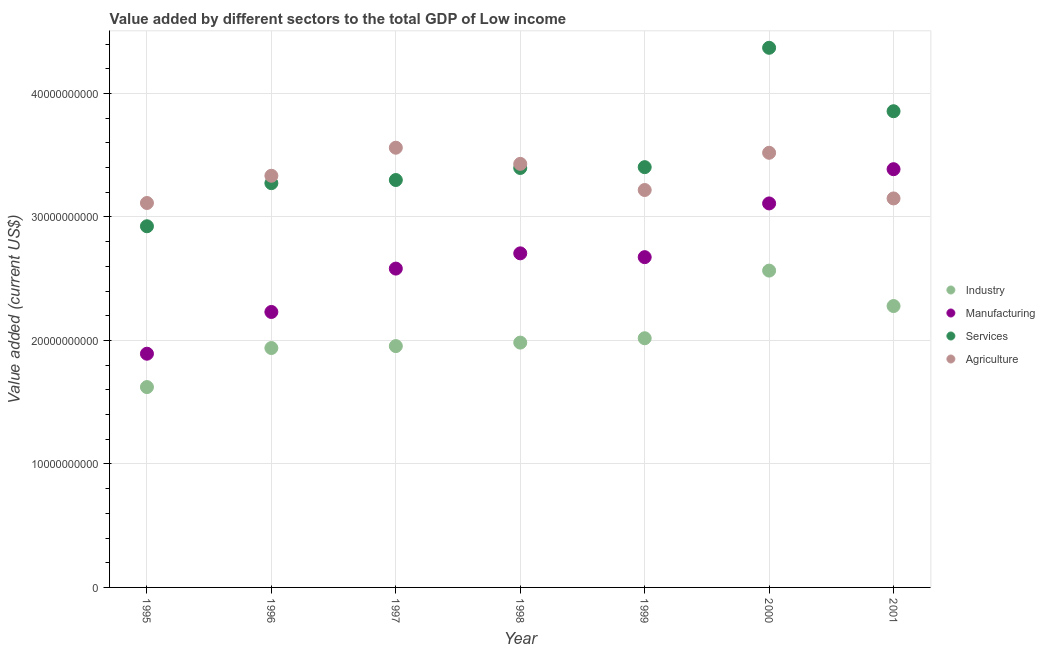What is the value added by manufacturing sector in 1998?
Provide a short and direct response. 2.70e+1. Across all years, what is the maximum value added by agricultural sector?
Offer a very short reply. 3.56e+1. Across all years, what is the minimum value added by manufacturing sector?
Your response must be concise. 1.89e+1. What is the total value added by industrial sector in the graph?
Offer a very short reply. 1.44e+11. What is the difference between the value added by services sector in 1996 and that in 1999?
Give a very brief answer. -1.30e+09. What is the difference between the value added by services sector in 2000 and the value added by industrial sector in 1996?
Ensure brevity in your answer.  2.43e+1. What is the average value added by industrial sector per year?
Your response must be concise. 2.05e+1. In the year 1996, what is the difference between the value added by agricultural sector and value added by manufacturing sector?
Keep it short and to the point. 1.10e+1. What is the ratio of the value added by industrial sector in 1995 to that in 1999?
Keep it short and to the point. 0.8. Is the value added by manufacturing sector in 1997 less than that in 1998?
Keep it short and to the point. Yes. What is the difference between the highest and the second highest value added by agricultural sector?
Keep it short and to the point. 4.10e+08. What is the difference between the highest and the lowest value added by services sector?
Your response must be concise. 1.45e+1. In how many years, is the value added by services sector greater than the average value added by services sector taken over all years?
Provide a short and direct response. 2. Is the sum of the value added by industrial sector in 1996 and 1999 greater than the maximum value added by agricultural sector across all years?
Your answer should be very brief. Yes. Is the value added by services sector strictly greater than the value added by industrial sector over the years?
Keep it short and to the point. Yes. Is the value added by manufacturing sector strictly less than the value added by agricultural sector over the years?
Give a very brief answer. No. How many years are there in the graph?
Your answer should be very brief. 7. What is the difference between two consecutive major ticks on the Y-axis?
Your answer should be compact. 1.00e+1. Are the values on the major ticks of Y-axis written in scientific E-notation?
Your answer should be very brief. No. Does the graph contain grids?
Your answer should be very brief. Yes. Where does the legend appear in the graph?
Your response must be concise. Center right. How are the legend labels stacked?
Make the answer very short. Vertical. What is the title of the graph?
Ensure brevity in your answer.  Value added by different sectors to the total GDP of Low income. Does "Overall level" appear as one of the legend labels in the graph?
Make the answer very short. No. What is the label or title of the X-axis?
Ensure brevity in your answer.  Year. What is the label or title of the Y-axis?
Offer a terse response. Value added (current US$). What is the Value added (current US$) in Industry in 1995?
Offer a very short reply. 1.62e+1. What is the Value added (current US$) of Manufacturing in 1995?
Give a very brief answer. 1.89e+1. What is the Value added (current US$) in Services in 1995?
Offer a terse response. 2.92e+1. What is the Value added (current US$) of Agriculture in 1995?
Provide a succinct answer. 3.11e+1. What is the Value added (current US$) of Industry in 1996?
Provide a short and direct response. 1.94e+1. What is the Value added (current US$) of Manufacturing in 1996?
Your response must be concise. 2.23e+1. What is the Value added (current US$) of Services in 1996?
Offer a very short reply. 3.27e+1. What is the Value added (current US$) in Agriculture in 1996?
Your answer should be very brief. 3.33e+1. What is the Value added (current US$) of Industry in 1997?
Make the answer very short. 1.95e+1. What is the Value added (current US$) of Manufacturing in 1997?
Provide a short and direct response. 2.58e+1. What is the Value added (current US$) of Services in 1997?
Provide a succinct answer. 3.30e+1. What is the Value added (current US$) in Agriculture in 1997?
Keep it short and to the point. 3.56e+1. What is the Value added (current US$) in Industry in 1998?
Your answer should be compact. 1.98e+1. What is the Value added (current US$) of Manufacturing in 1998?
Offer a very short reply. 2.70e+1. What is the Value added (current US$) of Services in 1998?
Offer a terse response. 3.40e+1. What is the Value added (current US$) of Agriculture in 1998?
Provide a succinct answer. 3.43e+1. What is the Value added (current US$) in Industry in 1999?
Provide a short and direct response. 2.02e+1. What is the Value added (current US$) of Manufacturing in 1999?
Keep it short and to the point. 2.67e+1. What is the Value added (current US$) in Services in 1999?
Your answer should be compact. 3.40e+1. What is the Value added (current US$) of Agriculture in 1999?
Your response must be concise. 3.22e+1. What is the Value added (current US$) in Industry in 2000?
Give a very brief answer. 2.57e+1. What is the Value added (current US$) of Manufacturing in 2000?
Make the answer very short. 3.11e+1. What is the Value added (current US$) in Services in 2000?
Provide a succinct answer. 4.37e+1. What is the Value added (current US$) of Agriculture in 2000?
Make the answer very short. 3.52e+1. What is the Value added (current US$) in Industry in 2001?
Your answer should be very brief. 2.28e+1. What is the Value added (current US$) in Manufacturing in 2001?
Offer a very short reply. 3.39e+1. What is the Value added (current US$) of Services in 2001?
Provide a short and direct response. 3.86e+1. What is the Value added (current US$) in Agriculture in 2001?
Offer a terse response. 3.15e+1. Across all years, what is the maximum Value added (current US$) of Industry?
Offer a terse response. 2.57e+1. Across all years, what is the maximum Value added (current US$) in Manufacturing?
Offer a very short reply. 3.39e+1. Across all years, what is the maximum Value added (current US$) in Services?
Your response must be concise. 4.37e+1. Across all years, what is the maximum Value added (current US$) in Agriculture?
Provide a succinct answer. 3.56e+1. Across all years, what is the minimum Value added (current US$) in Industry?
Offer a terse response. 1.62e+1. Across all years, what is the minimum Value added (current US$) in Manufacturing?
Offer a terse response. 1.89e+1. Across all years, what is the minimum Value added (current US$) of Services?
Offer a very short reply. 2.92e+1. Across all years, what is the minimum Value added (current US$) of Agriculture?
Provide a succinct answer. 3.11e+1. What is the total Value added (current US$) of Industry in the graph?
Ensure brevity in your answer.  1.44e+11. What is the total Value added (current US$) in Manufacturing in the graph?
Provide a short and direct response. 1.86e+11. What is the total Value added (current US$) of Services in the graph?
Ensure brevity in your answer.  2.45e+11. What is the total Value added (current US$) of Agriculture in the graph?
Your response must be concise. 2.33e+11. What is the difference between the Value added (current US$) in Industry in 1995 and that in 1996?
Offer a very short reply. -3.16e+09. What is the difference between the Value added (current US$) of Manufacturing in 1995 and that in 1996?
Offer a very short reply. -3.38e+09. What is the difference between the Value added (current US$) of Services in 1995 and that in 1996?
Offer a very short reply. -3.49e+09. What is the difference between the Value added (current US$) in Agriculture in 1995 and that in 1996?
Your answer should be very brief. -2.20e+09. What is the difference between the Value added (current US$) in Industry in 1995 and that in 1997?
Keep it short and to the point. -3.32e+09. What is the difference between the Value added (current US$) of Manufacturing in 1995 and that in 1997?
Offer a terse response. -6.89e+09. What is the difference between the Value added (current US$) in Services in 1995 and that in 1997?
Offer a very short reply. -3.74e+09. What is the difference between the Value added (current US$) of Agriculture in 1995 and that in 1997?
Offer a very short reply. -4.48e+09. What is the difference between the Value added (current US$) of Industry in 1995 and that in 1998?
Offer a very short reply. -3.60e+09. What is the difference between the Value added (current US$) in Manufacturing in 1995 and that in 1998?
Provide a short and direct response. -8.13e+09. What is the difference between the Value added (current US$) of Services in 1995 and that in 1998?
Your response must be concise. -4.72e+09. What is the difference between the Value added (current US$) in Agriculture in 1995 and that in 1998?
Ensure brevity in your answer.  -3.17e+09. What is the difference between the Value added (current US$) of Industry in 1995 and that in 1999?
Keep it short and to the point. -3.95e+09. What is the difference between the Value added (current US$) in Manufacturing in 1995 and that in 1999?
Provide a succinct answer. -7.82e+09. What is the difference between the Value added (current US$) in Services in 1995 and that in 1999?
Your response must be concise. -4.79e+09. What is the difference between the Value added (current US$) of Agriculture in 1995 and that in 1999?
Give a very brief answer. -1.05e+09. What is the difference between the Value added (current US$) of Industry in 1995 and that in 2000?
Offer a terse response. -9.43e+09. What is the difference between the Value added (current US$) in Manufacturing in 1995 and that in 2000?
Provide a succinct answer. -1.22e+1. What is the difference between the Value added (current US$) of Services in 1995 and that in 2000?
Your answer should be compact. -1.45e+1. What is the difference between the Value added (current US$) in Agriculture in 1995 and that in 2000?
Provide a short and direct response. -4.07e+09. What is the difference between the Value added (current US$) in Industry in 1995 and that in 2001?
Provide a short and direct response. -6.56e+09. What is the difference between the Value added (current US$) in Manufacturing in 1995 and that in 2001?
Your answer should be very brief. -1.49e+1. What is the difference between the Value added (current US$) of Services in 1995 and that in 2001?
Your answer should be compact. -9.31e+09. What is the difference between the Value added (current US$) of Agriculture in 1995 and that in 2001?
Give a very brief answer. -3.69e+08. What is the difference between the Value added (current US$) of Industry in 1996 and that in 1997?
Keep it short and to the point. -1.56e+08. What is the difference between the Value added (current US$) of Manufacturing in 1996 and that in 1997?
Give a very brief answer. -3.51e+09. What is the difference between the Value added (current US$) in Services in 1996 and that in 1997?
Give a very brief answer. -2.54e+08. What is the difference between the Value added (current US$) of Agriculture in 1996 and that in 1997?
Your response must be concise. -2.27e+09. What is the difference between the Value added (current US$) of Industry in 1996 and that in 1998?
Ensure brevity in your answer.  -4.39e+08. What is the difference between the Value added (current US$) in Manufacturing in 1996 and that in 1998?
Offer a very short reply. -4.75e+09. What is the difference between the Value added (current US$) of Services in 1996 and that in 1998?
Your response must be concise. -1.23e+09. What is the difference between the Value added (current US$) in Agriculture in 1996 and that in 1998?
Provide a short and direct response. -9.64e+08. What is the difference between the Value added (current US$) of Industry in 1996 and that in 1999?
Keep it short and to the point. -7.92e+08. What is the difference between the Value added (current US$) in Manufacturing in 1996 and that in 1999?
Make the answer very short. -4.44e+09. What is the difference between the Value added (current US$) of Services in 1996 and that in 1999?
Provide a short and direct response. -1.30e+09. What is the difference between the Value added (current US$) in Agriculture in 1996 and that in 1999?
Your answer should be compact. 1.15e+09. What is the difference between the Value added (current US$) in Industry in 1996 and that in 2000?
Your answer should be compact. -6.27e+09. What is the difference between the Value added (current US$) in Manufacturing in 1996 and that in 2000?
Your answer should be very brief. -8.79e+09. What is the difference between the Value added (current US$) in Services in 1996 and that in 2000?
Your response must be concise. -1.10e+1. What is the difference between the Value added (current US$) of Agriculture in 1996 and that in 2000?
Your answer should be very brief. -1.86e+09. What is the difference between the Value added (current US$) in Industry in 1996 and that in 2001?
Offer a very short reply. -3.40e+09. What is the difference between the Value added (current US$) in Manufacturing in 1996 and that in 2001?
Your response must be concise. -1.16e+1. What is the difference between the Value added (current US$) in Services in 1996 and that in 2001?
Your answer should be compact. -5.82e+09. What is the difference between the Value added (current US$) in Agriculture in 1996 and that in 2001?
Give a very brief answer. 1.84e+09. What is the difference between the Value added (current US$) of Industry in 1997 and that in 1998?
Provide a short and direct response. -2.83e+08. What is the difference between the Value added (current US$) of Manufacturing in 1997 and that in 1998?
Provide a short and direct response. -1.23e+09. What is the difference between the Value added (current US$) of Services in 1997 and that in 1998?
Keep it short and to the point. -9.76e+08. What is the difference between the Value added (current US$) of Agriculture in 1997 and that in 1998?
Provide a succinct answer. 1.31e+09. What is the difference between the Value added (current US$) in Industry in 1997 and that in 1999?
Your response must be concise. -6.36e+08. What is the difference between the Value added (current US$) of Manufacturing in 1997 and that in 1999?
Ensure brevity in your answer.  -9.26e+08. What is the difference between the Value added (current US$) of Services in 1997 and that in 1999?
Ensure brevity in your answer.  -1.04e+09. What is the difference between the Value added (current US$) in Agriculture in 1997 and that in 1999?
Provide a short and direct response. 3.42e+09. What is the difference between the Value added (current US$) in Industry in 1997 and that in 2000?
Offer a terse response. -6.11e+09. What is the difference between the Value added (current US$) of Manufacturing in 1997 and that in 2000?
Provide a short and direct response. -5.28e+09. What is the difference between the Value added (current US$) in Services in 1997 and that in 2000?
Provide a short and direct response. -1.07e+1. What is the difference between the Value added (current US$) in Agriculture in 1997 and that in 2000?
Keep it short and to the point. 4.10e+08. What is the difference between the Value added (current US$) in Industry in 1997 and that in 2001?
Make the answer very short. -3.24e+09. What is the difference between the Value added (current US$) in Manufacturing in 1997 and that in 2001?
Offer a very short reply. -8.05e+09. What is the difference between the Value added (current US$) in Services in 1997 and that in 2001?
Give a very brief answer. -5.57e+09. What is the difference between the Value added (current US$) of Agriculture in 1997 and that in 2001?
Keep it short and to the point. 4.11e+09. What is the difference between the Value added (current US$) of Industry in 1998 and that in 1999?
Offer a terse response. -3.53e+08. What is the difference between the Value added (current US$) in Manufacturing in 1998 and that in 1999?
Your response must be concise. 3.08e+08. What is the difference between the Value added (current US$) of Services in 1998 and that in 1999?
Make the answer very short. -6.67e+07. What is the difference between the Value added (current US$) in Agriculture in 1998 and that in 1999?
Your response must be concise. 2.12e+09. What is the difference between the Value added (current US$) of Industry in 1998 and that in 2000?
Your answer should be compact. -5.83e+09. What is the difference between the Value added (current US$) of Manufacturing in 1998 and that in 2000?
Provide a short and direct response. -4.04e+09. What is the difference between the Value added (current US$) of Services in 1998 and that in 2000?
Offer a very short reply. -9.73e+09. What is the difference between the Value added (current US$) in Agriculture in 1998 and that in 2000?
Your answer should be compact. -8.97e+08. What is the difference between the Value added (current US$) of Industry in 1998 and that in 2001?
Provide a short and direct response. -2.96e+09. What is the difference between the Value added (current US$) in Manufacturing in 1998 and that in 2001?
Provide a short and direct response. -6.81e+09. What is the difference between the Value added (current US$) in Services in 1998 and that in 2001?
Your answer should be compact. -4.59e+09. What is the difference between the Value added (current US$) of Agriculture in 1998 and that in 2001?
Provide a succinct answer. 2.80e+09. What is the difference between the Value added (current US$) of Industry in 1999 and that in 2000?
Offer a very short reply. -5.48e+09. What is the difference between the Value added (current US$) of Manufacturing in 1999 and that in 2000?
Give a very brief answer. -4.35e+09. What is the difference between the Value added (current US$) in Services in 1999 and that in 2000?
Offer a terse response. -9.66e+09. What is the difference between the Value added (current US$) in Agriculture in 1999 and that in 2000?
Keep it short and to the point. -3.01e+09. What is the difference between the Value added (current US$) of Industry in 1999 and that in 2001?
Offer a very short reply. -2.61e+09. What is the difference between the Value added (current US$) in Manufacturing in 1999 and that in 2001?
Make the answer very short. -7.12e+09. What is the difference between the Value added (current US$) in Services in 1999 and that in 2001?
Ensure brevity in your answer.  -4.53e+09. What is the difference between the Value added (current US$) of Agriculture in 1999 and that in 2001?
Provide a short and direct response. 6.83e+08. What is the difference between the Value added (current US$) in Industry in 2000 and that in 2001?
Your answer should be compact. 2.87e+09. What is the difference between the Value added (current US$) of Manufacturing in 2000 and that in 2001?
Give a very brief answer. -2.77e+09. What is the difference between the Value added (current US$) of Services in 2000 and that in 2001?
Give a very brief answer. 5.14e+09. What is the difference between the Value added (current US$) of Agriculture in 2000 and that in 2001?
Ensure brevity in your answer.  3.70e+09. What is the difference between the Value added (current US$) of Industry in 1995 and the Value added (current US$) of Manufacturing in 1996?
Offer a terse response. -6.08e+09. What is the difference between the Value added (current US$) in Industry in 1995 and the Value added (current US$) in Services in 1996?
Keep it short and to the point. -1.65e+1. What is the difference between the Value added (current US$) of Industry in 1995 and the Value added (current US$) of Agriculture in 1996?
Make the answer very short. -1.71e+1. What is the difference between the Value added (current US$) in Manufacturing in 1995 and the Value added (current US$) in Services in 1996?
Keep it short and to the point. -1.38e+1. What is the difference between the Value added (current US$) in Manufacturing in 1995 and the Value added (current US$) in Agriculture in 1996?
Ensure brevity in your answer.  -1.44e+1. What is the difference between the Value added (current US$) in Services in 1995 and the Value added (current US$) in Agriculture in 1996?
Your response must be concise. -4.09e+09. What is the difference between the Value added (current US$) of Industry in 1995 and the Value added (current US$) of Manufacturing in 1997?
Your answer should be compact. -9.59e+09. What is the difference between the Value added (current US$) in Industry in 1995 and the Value added (current US$) in Services in 1997?
Ensure brevity in your answer.  -1.68e+1. What is the difference between the Value added (current US$) in Industry in 1995 and the Value added (current US$) in Agriculture in 1997?
Your answer should be compact. -1.94e+1. What is the difference between the Value added (current US$) in Manufacturing in 1995 and the Value added (current US$) in Services in 1997?
Keep it short and to the point. -1.41e+1. What is the difference between the Value added (current US$) of Manufacturing in 1995 and the Value added (current US$) of Agriculture in 1997?
Make the answer very short. -1.67e+1. What is the difference between the Value added (current US$) of Services in 1995 and the Value added (current US$) of Agriculture in 1997?
Your answer should be very brief. -6.36e+09. What is the difference between the Value added (current US$) of Industry in 1995 and the Value added (current US$) of Manufacturing in 1998?
Your response must be concise. -1.08e+1. What is the difference between the Value added (current US$) in Industry in 1995 and the Value added (current US$) in Services in 1998?
Provide a short and direct response. -1.77e+1. What is the difference between the Value added (current US$) in Industry in 1995 and the Value added (current US$) in Agriculture in 1998?
Your answer should be compact. -1.81e+1. What is the difference between the Value added (current US$) in Manufacturing in 1995 and the Value added (current US$) in Services in 1998?
Offer a very short reply. -1.50e+1. What is the difference between the Value added (current US$) in Manufacturing in 1995 and the Value added (current US$) in Agriculture in 1998?
Keep it short and to the point. -1.54e+1. What is the difference between the Value added (current US$) of Services in 1995 and the Value added (current US$) of Agriculture in 1998?
Offer a terse response. -5.05e+09. What is the difference between the Value added (current US$) in Industry in 1995 and the Value added (current US$) in Manufacturing in 1999?
Offer a terse response. -1.05e+1. What is the difference between the Value added (current US$) of Industry in 1995 and the Value added (current US$) of Services in 1999?
Your answer should be very brief. -1.78e+1. What is the difference between the Value added (current US$) of Industry in 1995 and the Value added (current US$) of Agriculture in 1999?
Your answer should be compact. -1.60e+1. What is the difference between the Value added (current US$) of Manufacturing in 1995 and the Value added (current US$) of Services in 1999?
Your answer should be compact. -1.51e+1. What is the difference between the Value added (current US$) of Manufacturing in 1995 and the Value added (current US$) of Agriculture in 1999?
Offer a very short reply. -1.33e+1. What is the difference between the Value added (current US$) of Services in 1995 and the Value added (current US$) of Agriculture in 1999?
Provide a succinct answer. -2.94e+09. What is the difference between the Value added (current US$) of Industry in 1995 and the Value added (current US$) of Manufacturing in 2000?
Provide a succinct answer. -1.49e+1. What is the difference between the Value added (current US$) in Industry in 1995 and the Value added (current US$) in Services in 2000?
Give a very brief answer. -2.75e+1. What is the difference between the Value added (current US$) of Industry in 1995 and the Value added (current US$) of Agriculture in 2000?
Provide a short and direct response. -1.90e+1. What is the difference between the Value added (current US$) of Manufacturing in 1995 and the Value added (current US$) of Services in 2000?
Make the answer very short. -2.48e+1. What is the difference between the Value added (current US$) in Manufacturing in 1995 and the Value added (current US$) in Agriculture in 2000?
Keep it short and to the point. -1.63e+1. What is the difference between the Value added (current US$) in Services in 1995 and the Value added (current US$) in Agriculture in 2000?
Ensure brevity in your answer.  -5.95e+09. What is the difference between the Value added (current US$) in Industry in 1995 and the Value added (current US$) in Manufacturing in 2001?
Provide a succinct answer. -1.76e+1. What is the difference between the Value added (current US$) of Industry in 1995 and the Value added (current US$) of Services in 2001?
Make the answer very short. -2.23e+1. What is the difference between the Value added (current US$) in Industry in 1995 and the Value added (current US$) in Agriculture in 2001?
Your response must be concise. -1.53e+1. What is the difference between the Value added (current US$) in Manufacturing in 1995 and the Value added (current US$) in Services in 2001?
Offer a terse response. -1.96e+1. What is the difference between the Value added (current US$) in Manufacturing in 1995 and the Value added (current US$) in Agriculture in 2001?
Your response must be concise. -1.26e+1. What is the difference between the Value added (current US$) in Services in 1995 and the Value added (current US$) in Agriculture in 2001?
Make the answer very short. -2.25e+09. What is the difference between the Value added (current US$) of Industry in 1996 and the Value added (current US$) of Manufacturing in 1997?
Offer a very short reply. -6.43e+09. What is the difference between the Value added (current US$) of Industry in 1996 and the Value added (current US$) of Services in 1997?
Your response must be concise. -1.36e+1. What is the difference between the Value added (current US$) in Industry in 1996 and the Value added (current US$) in Agriculture in 1997?
Your answer should be compact. -1.62e+1. What is the difference between the Value added (current US$) in Manufacturing in 1996 and the Value added (current US$) in Services in 1997?
Ensure brevity in your answer.  -1.07e+1. What is the difference between the Value added (current US$) in Manufacturing in 1996 and the Value added (current US$) in Agriculture in 1997?
Keep it short and to the point. -1.33e+1. What is the difference between the Value added (current US$) in Services in 1996 and the Value added (current US$) in Agriculture in 1997?
Your response must be concise. -2.87e+09. What is the difference between the Value added (current US$) in Industry in 1996 and the Value added (current US$) in Manufacturing in 1998?
Make the answer very short. -7.67e+09. What is the difference between the Value added (current US$) in Industry in 1996 and the Value added (current US$) in Services in 1998?
Provide a short and direct response. -1.46e+1. What is the difference between the Value added (current US$) in Industry in 1996 and the Value added (current US$) in Agriculture in 1998?
Make the answer very short. -1.49e+1. What is the difference between the Value added (current US$) of Manufacturing in 1996 and the Value added (current US$) of Services in 1998?
Offer a terse response. -1.17e+1. What is the difference between the Value added (current US$) of Manufacturing in 1996 and the Value added (current US$) of Agriculture in 1998?
Your response must be concise. -1.20e+1. What is the difference between the Value added (current US$) of Services in 1996 and the Value added (current US$) of Agriculture in 1998?
Provide a short and direct response. -1.56e+09. What is the difference between the Value added (current US$) of Industry in 1996 and the Value added (current US$) of Manufacturing in 1999?
Make the answer very short. -7.36e+09. What is the difference between the Value added (current US$) in Industry in 1996 and the Value added (current US$) in Services in 1999?
Your answer should be compact. -1.46e+1. What is the difference between the Value added (current US$) of Industry in 1996 and the Value added (current US$) of Agriculture in 1999?
Keep it short and to the point. -1.28e+1. What is the difference between the Value added (current US$) in Manufacturing in 1996 and the Value added (current US$) in Services in 1999?
Offer a terse response. -1.17e+1. What is the difference between the Value added (current US$) in Manufacturing in 1996 and the Value added (current US$) in Agriculture in 1999?
Give a very brief answer. -9.88e+09. What is the difference between the Value added (current US$) in Services in 1996 and the Value added (current US$) in Agriculture in 1999?
Ensure brevity in your answer.  5.54e+08. What is the difference between the Value added (current US$) in Industry in 1996 and the Value added (current US$) in Manufacturing in 2000?
Your response must be concise. -1.17e+1. What is the difference between the Value added (current US$) in Industry in 1996 and the Value added (current US$) in Services in 2000?
Provide a short and direct response. -2.43e+1. What is the difference between the Value added (current US$) of Industry in 1996 and the Value added (current US$) of Agriculture in 2000?
Offer a terse response. -1.58e+1. What is the difference between the Value added (current US$) in Manufacturing in 1996 and the Value added (current US$) in Services in 2000?
Keep it short and to the point. -2.14e+1. What is the difference between the Value added (current US$) of Manufacturing in 1996 and the Value added (current US$) of Agriculture in 2000?
Offer a very short reply. -1.29e+1. What is the difference between the Value added (current US$) of Services in 1996 and the Value added (current US$) of Agriculture in 2000?
Your answer should be compact. -2.46e+09. What is the difference between the Value added (current US$) of Industry in 1996 and the Value added (current US$) of Manufacturing in 2001?
Your response must be concise. -1.45e+1. What is the difference between the Value added (current US$) of Industry in 1996 and the Value added (current US$) of Services in 2001?
Make the answer very short. -1.92e+1. What is the difference between the Value added (current US$) in Industry in 1996 and the Value added (current US$) in Agriculture in 2001?
Ensure brevity in your answer.  -1.21e+1. What is the difference between the Value added (current US$) in Manufacturing in 1996 and the Value added (current US$) in Services in 2001?
Make the answer very short. -1.63e+1. What is the difference between the Value added (current US$) of Manufacturing in 1996 and the Value added (current US$) of Agriculture in 2001?
Give a very brief answer. -9.19e+09. What is the difference between the Value added (current US$) of Services in 1996 and the Value added (current US$) of Agriculture in 2001?
Ensure brevity in your answer.  1.24e+09. What is the difference between the Value added (current US$) in Industry in 1997 and the Value added (current US$) in Manufacturing in 1998?
Your answer should be very brief. -7.51e+09. What is the difference between the Value added (current US$) of Industry in 1997 and the Value added (current US$) of Services in 1998?
Provide a succinct answer. -1.44e+1. What is the difference between the Value added (current US$) in Industry in 1997 and the Value added (current US$) in Agriculture in 1998?
Provide a succinct answer. -1.48e+1. What is the difference between the Value added (current US$) of Manufacturing in 1997 and the Value added (current US$) of Services in 1998?
Provide a succinct answer. -8.15e+09. What is the difference between the Value added (current US$) of Manufacturing in 1997 and the Value added (current US$) of Agriculture in 1998?
Keep it short and to the point. -8.48e+09. What is the difference between the Value added (current US$) in Services in 1997 and the Value added (current US$) in Agriculture in 1998?
Your answer should be very brief. -1.31e+09. What is the difference between the Value added (current US$) in Industry in 1997 and the Value added (current US$) in Manufacturing in 1999?
Offer a terse response. -7.20e+09. What is the difference between the Value added (current US$) in Industry in 1997 and the Value added (current US$) in Services in 1999?
Give a very brief answer. -1.45e+1. What is the difference between the Value added (current US$) in Industry in 1997 and the Value added (current US$) in Agriculture in 1999?
Keep it short and to the point. -1.26e+1. What is the difference between the Value added (current US$) in Manufacturing in 1997 and the Value added (current US$) in Services in 1999?
Your response must be concise. -8.21e+09. What is the difference between the Value added (current US$) of Manufacturing in 1997 and the Value added (current US$) of Agriculture in 1999?
Provide a short and direct response. -6.36e+09. What is the difference between the Value added (current US$) in Services in 1997 and the Value added (current US$) in Agriculture in 1999?
Provide a succinct answer. 8.08e+08. What is the difference between the Value added (current US$) of Industry in 1997 and the Value added (current US$) of Manufacturing in 2000?
Provide a short and direct response. -1.16e+1. What is the difference between the Value added (current US$) of Industry in 1997 and the Value added (current US$) of Services in 2000?
Your answer should be compact. -2.42e+1. What is the difference between the Value added (current US$) of Industry in 1997 and the Value added (current US$) of Agriculture in 2000?
Your response must be concise. -1.57e+1. What is the difference between the Value added (current US$) in Manufacturing in 1997 and the Value added (current US$) in Services in 2000?
Your answer should be compact. -1.79e+1. What is the difference between the Value added (current US$) of Manufacturing in 1997 and the Value added (current US$) of Agriculture in 2000?
Your response must be concise. -9.38e+09. What is the difference between the Value added (current US$) of Services in 1997 and the Value added (current US$) of Agriculture in 2000?
Offer a very short reply. -2.21e+09. What is the difference between the Value added (current US$) in Industry in 1997 and the Value added (current US$) in Manufacturing in 2001?
Provide a succinct answer. -1.43e+1. What is the difference between the Value added (current US$) in Industry in 1997 and the Value added (current US$) in Services in 2001?
Ensure brevity in your answer.  -1.90e+1. What is the difference between the Value added (current US$) in Industry in 1997 and the Value added (current US$) in Agriculture in 2001?
Offer a very short reply. -1.20e+1. What is the difference between the Value added (current US$) of Manufacturing in 1997 and the Value added (current US$) of Services in 2001?
Make the answer very short. -1.27e+1. What is the difference between the Value added (current US$) of Manufacturing in 1997 and the Value added (current US$) of Agriculture in 2001?
Offer a terse response. -5.68e+09. What is the difference between the Value added (current US$) of Services in 1997 and the Value added (current US$) of Agriculture in 2001?
Your response must be concise. 1.49e+09. What is the difference between the Value added (current US$) of Industry in 1998 and the Value added (current US$) of Manufacturing in 1999?
Keep it short and to the point. -6.92e+09. What is the difference between the Value added (current US$) of Industry in 1998 and the Value added (current US$) of Services in 1999?
Your response must be concise. -1.42e+1. What is the difference between the Value added (current US$) in Industry in 1998 and the Value added (current US$) in Agriculture in 1999?
Offer a very short reply. -1.24e+1. What is the difference between the Value added (current US$) of Manufacturing in 1998 and the Value added (current US$) of Services in 1999?
Your answer should be very brief. -6.98e+09. What is the difference between the Value added (current US$) in Manufacturing in 1998 and the Value added (current US$) in Agriculture in 1999?
Your response must be concise. -5.13e+09. What is the difference between the Value added (current US$) in Services in 1998 and the Value added (current US$) in Agriculture in 1999?
Your response must be concise. 1.78e+09. What is the difference between the Value added (current US$) of Industry in 1998 and the Value added (current US$) of Manufacturing in 2000?
Give a very brief answer. -1.13e+1. What is the difference between the Value added (current US$) of Industry in 1998 and the Value added (current US$) of Services in 2000?
Make the answer very short. -2.39e+1. What is the difference between the Value added (current US$) in Industry in 1998 and the Value added (current US$) in Agriculture in 2000?
Keep it short and to the point. -1.54e+1. What is the difference between the Value added (current US$) of Manufacturing in 1998 and the Value added (current US$) of Services in 2000?
Provide a succinct answer. -1.66e+1. What is the difference between the Value added (current US$) in Manufacturing in 1998 and the Value added (current US$) in Agriculture in 2000?
Your response must be concise. -8.14e+09. What is the difference between the Value added (current US$) of Services in 1998 and the Value added (current US$) of Agriculture in 2000?
Your answer should be very brief. -1.23e+09. What is the difference between the Value added (current US$) of Industry in 1998 and the Value added (current US$) of Manufacturing in 2001?
Make the answer very short. -1.40e+1. What is the difference between the Value added (current US$) in Industry in 1998 and the Value added (current US$) in Services in 2001?
Keep it short and to the point. -1.87e+1. What is the difference between the Value added (current US$) of Industry in 1998 and the Value added (current US$) of Agriculture in 2001?
Provide a short and direct response. -1.17e+1. What is the difference between the Value added (current US$) in Manufacturing in 1998 and the Value added (current US$) in Services in 2001?
Your answer should be very brief. -1.15e+1. What is the difference between the Value added (current US$) of Manufacturing in 1998 and the Value added (current US$) of Agriculture in 2001?
Offer a very short reply. -4.45e+09. What is the difference between the Value added (current US$) in Services in 1998 and the Value added (current US$) in Agriculture in 2001?
Your response must be concise. 2.47e+09. What is the difference between the Value added (current US$) of Industry in 1999 and the Value added (current US$) of Manufacturing in 2000?
Make the answer very short. -1.09e+1. What is the difference between the Value added (current US$) of Industry in 1999 and the Value added (current US$) of Services in 2000?
Your answer should be very brief. -2.35e+1. What is the difference between the Value added (current US$) of Industry in 1999 and the Value added (current US$) of Agriculture in 2000?
Provide a short and direct response. -1.50e+1. What is the difference between the Value added (current US$) of Manufacturing in 1999 and the Value added (current US$) of Services in 2000?
Your answer should be compact. -1.70e+1. What is the difference between the Value added (current US$) of Manufacturing in 1999 and the Value added (current US$) of Agriculture in 2000?
Your answer should be compact. -8.45e+09. What is the difference between the Value added (current US$) of Services in 1999 and the Value added (current US$) of Agriculture in 2000?
Your response must be concise. -1.16e+09. What is the difference between the Value added (current US$) in Industry in 1999 and the Value added (current US$) in Manufacturing in 2001?
Your answer should be compact. -1.37e+1. What is the difference between the Value added (current US$) in Industry in 1999 and the Value added (current US$) in Services in 2001?
Ensure brevity in your answer.  -1.84e+1. What is the difference between the Value added (current US$) in Industry in 1999 and the Value added (current US$) in Agriculture in 2001?
Your answer should be very brief. -1.13e+1. What is the difference between the Value added (current US$) in Manufacturing in 1999 and the Value added (current US$) in Services in 2001?
Offer a terse response. -1.18e+1. What is the difference between the Value added (current US$) of Manufacturing in 1999 and the Value added (current US$) of Agriculture in 2001?
Your answer should be very brief. -4.75e+09. What is the difference between the Value added (current US$) in Services in 1999 and the Value added (current US$) in Agriculture in 2001?
Provide a succinct answer. 2.53e+09. What is the difference between the Value added (current US$) in Industry in 2000 and the Value added (current US$) in Manufacturing in 2001?
Your response must be concise. -8.21e+09. What is the difference between the Value added (current US$) in Industry in 2000 and the Value added (current US$) in Services in 2001?
Provide a succinct answer. -1.29e+1. What is the difference between the Value added (current US$) in Industry in 2000 and the Value added (current US$) in Agriculture in 2001?
Ensure brevity in your answer.  -5.84e+09. What is the difference between the Value added (current US$) in Manufacturing in 2000 and the Value added (current US$) in Services in 2001?
Offer a terse response. -7.47e+09. What is the difference between the Value added (current US$) of Manufacturing in 2000 and the Value added (current US$) of Agriculture in 2001?
Give a very brief answer. -4.04e+08. What is the difference between the Value added (current US$) in Services in 2000 and the Value added (current US$) in Agriculture in 2001?
Your response must be concise. 1.22e+1. What is the average Value added (current US$) of Industry per year?
Offer a very short reply. 2.05e+1. What is the average Value added (current US$) of Manufacturing per year?
Offer a terse response. 2.65e+1. What is the average Value added (current US$) of Services per year?
Your answer should be very brief. 3.50e+1. What is the average Value added (current US$) of Agriculture per year?
Ensure brevity in your answer.  3.33e+1. In the year 1995, what is the difference between the Value added (current US$) of Industry and Value added (current US$) of Manufacturing?
Offer a terse response. -2.70e+09. In the year 1995, what is the difference between the Value added (current US$) of Industry and Value added (current US$) of Services?
Keep it short and to the point. -1.30e+1. In the year 1995, what is the difference between the Value added (current US$) of Industry and Value added (current US$) of Agriculture?
Provide a short and direct response. -1.49e+1. In the year 1995, what is the difference between the Value added (current US$) in Manufacturing and Value added (current US$) in Services?
Provide a succinct answer. -1.03e+1. In the year 1995, what is the difference between the Value added (current US$) of Manufacturing and Value added (current US$) of Agriculture?
Offer a terse response. -1.22e+1. In the year 1995, what is the difference between the Value added (current US$) of Services and Value added (current US$) of Agriculture?
Offer a terse response. -1.88e+09. In the year 1996, what is the difference between the Value added (current US$) of Industry and Value added (current US$) of Manufacturing?
Ensure brevity in your answer.  -2.92e+09. In the year 1996, what is the difference between the Value added (current US$) of Industry and Value added (current US$) of Services?
Give a very brief answer. -1.33e+1. In the year 1996, what is the difference between the Value added (current US$) of Industry and Value added (current US$) of Agriculture?
Keep it short and to the point. -1.39e+1. In the year 1996, what is the difference between the Value added (current US$) of Manufacturing and Value added (current US$) of Services?
Make the answer very short. -1.04e+1. In the year 1996, what is the difference between the Value added (current US$) in Manufacturing and Value added (current US$) in Agriculture?
Your answer should be very brief. -1.10e+1. In the year 1996, what is the difference between the Value added (current US$) of Services and Value added (current US$) of Agriculture?
Your answer should be very brief. -5.98e+08. In the year 1997, what is the difference between the Value added (current US$) of Industry and Value added (current US$) of Manufacturing?
Provide a succinct answer. -6.28e+09. In the year 1997, what is the difference between the Value added (current US$) of Industry and Value added (current US$) of Services?
Your answer should be very brief. -1.34e+1. In the year 1997, what is the difference between the Value added (current US$) in Industry and Value added (current US$) in Agriculture?
Your answer should be very brief. -1.61e+1. In the year 1997, what is the difference between the Value added (current US$) of Manufacturing and Value added (current US$) of Services?
Your response must be concise. -7.17e+09. In the year 1997, what is the difference between the Value added (current US$) of Manufacturing and Value added (current US$) of Agriculture?
Give a very brief answer. -9.79e+09. In the year 1997, what is the difference between the Value added (current US$) of Services and Value added (current US$) of Agriculture?
Give a very brief answer. -2.62e+09. In the year 1998, what is the difference between the Value added (current US$) in Industry and Value added (current US$) in Manufacturing?
Offer a very short reply. -7.23e+09. In the year 1998, what is the difference between the Value added (current US$) of Industry and Value added (current US$) of Services?
Provide a succinct answer. -1.41e+1. In the year 1998, what is the difference between the Value added (current US$) of Industry and Value added (current US$) of Agriculture?
Keep it short and to the point. -1.45e+1. In the year 1998, what is the difference between the Value added (current US$) in Manufacturing and Value added (current US$) in Services?
Offer a terse response. -6.91e+09. In the year 1998, what is the difference between the Value added (current US$) of Manufacturing and Value added (current US$) of Agriculture?
Provide a succinct answer. -7.25e+09. In the year 1998, what is the difference between the Value added (current US$) of Services and Value added (current US$) of Agriculture?
Your response must be concise. -3.32e+08. In the year 1999, what is the difference between the Value added (current US$) in Industry and Value added (current US$) in Manufacturing?
Keep it short and to the point. -6.57e+09. In the year 1999, what is the difference between the Value added (current US$) of Industry and Value added (current US$) of Services?
Ensure brevity in your answer.  -1.39e+1. In the year 1999, what is the difference between the Value added (current US$) in Industry and Value added (current US$) in Agriculture?
Offer a terse response. -1.20e+1. In the year 1999, what is the difference between the Value added (current US$) in Manufacturing and Value added (current US$) in Services?
Your answer should be compact. -7.29e+09. In the year 1999, what is the difference between the Value added (current US$) in Manufacturing and Value added (current US$) in Agriculture?
Provide a short and direct response. -5.44e+09. In the year 1999, what is the difference between the Value added (current US$) in Services and Value added (current US$) in Agriculture?
Ensure brevity in your answer.  1.85e+09. In the year 2000, what is the difference between the Value added (current US$) of Industry and Value added (current US$) of Manufacturing?
Give a very brief answer. -5.44e+09. In the year 2000, what is the difference between the Value added (current US$) of Industry and Value added (current US$) of Services?
Ensure brevity in your answer.  -1.80e+1. In the year 2000, what is the difference between the Value added (current US$) of Industry and Value added (current US$) of Agriculture?
Your response must be concise. -9.54e+09. In the year 2000, what is the difference between the Value added (current US$) in Manufacturing and Value added (current US$) in Services?
Give a very brief answer. -1.26e+1. In the year 2000, what is the difference between the Value added (current US$) in Manufacturing and Value added (current US$) in Agriculture?
Your response must be concise. -4.10e+09. In the year 2000, what is the difference between the Value added (current US$) in Services and Value added (current US$) in Agriculture?
Your response must be concise. 8.50e+09. In the year 2001, what is the difference between the Value added (current US$) in Industry and Value added (current US$) in Manufacturing?
Your answer should be very brief. -1.11e+1. In the year 2001, what is the difference between the Value added (current US$) of Industry and Value added (current US$) of Services?
Make the answer very short. -1.58e+1. In the year 2001, what is the difference between the Value added (current US$) of Industry and Value added (current US$) of Agriculture?
Provide a succinct answer. -8.71e+09. In the year 2001, what is the difference between the Value added (current US$) of Manufacturing and Value added (current US$) of Services?
Provide a short and direct response. -4.69e+09. In the year 2001, what is the difference between the Value added (current US$) of Manufacturing and Value added (current US$) of Agriculture?
Offer a very short reply. 2.37e+09. In the year 2001, what is the difference between the Value added (current US$) of Services and Value added (current US$) of Agriculture?
Give a very brief answer. 7.06e+09. What is the ratio of the Value added (current US$) of Industry in 1995 to that in 1996?
Give a very brief answer. 0.84. What is the ratio of the Value added (current US$) of Manufacturing in 1995 to that in 1996?
Your response must be concise. 0.85. What is the ratio of the Value added (current US$) in Services in 1995 to that in 1996?
Keep it short and to the point. 0.89. What is the ratio of the Value added (current US$) of Agriculture in 1995 to that in 1996?
Your answer should be compact. 0.93. What is the ratio of the Value added (current US$) in Industry in 1995 to that in 1997?
Keep it short and to the point. 0.83. What is the ratio of the Value added (current US$) in Manufacturing in 1995 to that in 1997?
Give a very brief answer. 0.73. What is the ratio of the Value added (current US$) in Services in 1995 to that in 1997?
Give a very brief answer. 0.89. What is the ratio of the Value added (current US$) of Agriculture in 1995 to that in 1997?
Make the answer very short. 0.87. What is the ratio of the Value added (current US$) of Industry in 1995 to that in 1998?
Give a very brief answer. 0.82. What is the ratio of the Value added (current US$) in Manufacturing in 1995 to that in 1998?
Provide a succinct answer. 0.7. What is the ratio of the Value added (current US$) in Services in 1995 to that in 1998?
Ensure brevity in your answer.  0.86. What is the ratio of the Value added (current US$) in Agriculture in 1995 to that in 1998?
Make the answer very short. 0.91. What is the ratio of the Value added (current US$) in Industry in 1995 to that in 1999?
Offer a terse response. 0.8. What is the ratio of the Value added (current US$) of Manufacturing in 1995 to that in 1999?
Provide a succinct answer. 0.71. What is the ratio of the Value added (current US$) in Services in 1995 to that in 1999?
Ensure brevity in your answer.  0.86. What is the ratio of the Value added (current US$) in Agriculture in 1995 to that in 1999?
Your answer should be compact. 0.97. What is the ratio of the Value added (current US$) of Industry in 1995 to that in 2000?
Your answer should be compact. 0.63. What is the ratio of the Value added (current US$) of Manufacturing in 1995 to that in 2000?
Your answer should be very brief. 0.61. What is the ratio of the Value added (current US$) in Services in 1995 to that in 2000?
Provide a succinct answer. 0.67. What is the ratio of the Value added (current US$) of Agriculture in 1995 to that in 2000?
Provide a short and direct response. 0.88. What is the ratio of the Value added (current US$) in Industry in 1995 to that in 2001?
Offer a very short reply. 0.71. What is the ratio of the Value added (current US$) of Manufacturing in 1995 to that in 2001?
Provide a succinct answer. 0.56. What is the ratio of the Value added (current US$) of Services in 1995 to that in 2001?
Your response must be concise. 0.76. What is the ratio of the Value added (current US$) in Agriculture in 1995 to that in 2001?
Ensure brevity in your answer.  0.99. What is the ratio of the Value added (current US$) in Industry in 1996 to that in 1997?
Give a very brief answer. 0.99. What is the ratio of the Value added (current US$) of Manufacturing in 1996 to that in 1997?
Offer a terse response. 0.86. What is the ratio of the Value added (current US$) of Agriculture in 1996 to that in 1997?
Your answer should be compact. 0.94. What is the ratio of the Value added (current US$) in Industry in 1996 to that in 1998?
Make the answer very short. 0.98. What is the ratio of the Value added (current US$) in Manufacturing in 1996 to that in 1998?
Provide a short and direct response. 0.82. What is the ratio of the Value added (current US$) in Services in 1996 to that in 1998?
Your answer should be very brief. 0.96. What is the ratio of the Value added (current US$) of Agriculture in 1996 to that in 1998?
Provide a short and direct response. 0.97. What is the ratio of the Value added (current US$) in Industry in 1996 to that in 1999?
Make the answer very short. 0.96. What is the ratio of the Value added (current US$) in Manufacturing in 1996 to that in 1999?
Ensure brevity in your answer.  0.83. What is the ratio of the Value added (current US$) in Services in 1996 to that in 1999?
Your response must be concise. 0.96. What is the ratio of the Value added (current US$) of Agriculture in 1996 to that in 1999?
Your answer should be compact. 1.04. What is the ratio of the Value added (current US$) of Industry in 1996 to that in 2000?
Your answer should be compact. 0.76. What is the ratio of the Value added (current US$) in Manufacturing in 1996 to that in 2000?
Your answer should be very brief. 0.72. What is the ratio of the Value added (current US$) of Services in 1996 to that in 2000?
Offer a very short reply. 0.75. What is the ratio of the Value added (current US$) of Agriculture in 1996 to that in 2000?
Your answer should be very brief. 0.95. What is the ratio of the Value added (current US$) in Industry in 1996 to that in 2001?
Give a very brief answer. 0.85. What is the ratio of the Value added (current US$) in Manufacturing in 1996 to that in 2001?
Keep it short and to the point. 0.66. What is the ratio of the Value added (current US$) in Services in 1996 to that in 2001?
Ensure brevity in your answer.  0.85. What is the ratio of the Value added (current US$) of Agriculture in 1996 to that in 2001?
Make the answer very short. 1.06. What is the ratio of the Value added (current US$) of Industry in 1997 to that in 1998?
Keep it short and to the point. 0.99. What is the ratio of the Value added (current US$) in Manufacturing in 1997 to that in 1998?
Provide a short and direct response. 0.95. What is the ratio of the Value added (current US$) in Services in 1997 to that in 1998?
Provide a succinct answer. 0.97. What is the ratio of the Value added (current US$) of Agriculture in 1997 to that in 1998?
Provide a succinct answer. 1.04. What is the ratio of the Value added (current US$) in Industry in 1997 to that in 1999?
Your answer should be compact. 0.97. What is the ratio of the Value added (current US$) in Manufacturing in 1997 to that in 1999?
Keep it short and to the point. 0.97. What is the ratio of the Value added (current US$) of Services in 1997 to that in 1999?
Offer a terse response. 0.97. What is the ratio of the Value added (current US$) in Agriculture in 1997 to that in 1999?
Provide a short and direct response. 1.11. What is the ratio of the Value added (current US$) in Industry in 1997 to that in 2000?
Your answer should be compact. 0.76. What is the ratio of the Value added (current US$) in Manufacturing in 1997 to that in 2000?
Ensure brevity in your answer.  0.83. What is the ratio of the Value added (current US$) of Services in 1997 to that in 2000?
Provide a succinct answer. 0.76. What is the ratio of the Value added (current US$) of Agriculture in 1997 to that in 2000?
Your response must be concise. 1.01. What is the ratio of the Value added (current US$) of Industry in 1997 to that in 2001?
Ensure brevity in your answer.  0.86. What is the ratio of the Value added (current US$) of Manufacturing in 1997 to that in 2001?
Your answer should be very brief. 0.76. What is the ratio of the Value added (current US$) in Services in 1997 to that in 2001?
Give a very brief answer. 0.86. What is the ratio of the Value added (current US$) in Agriculture in 1997 to that in 2001?
Your response must be concise. 1.13. What is the ratio of the Value added (current US$) in Industry in 1998 to that in 1999?
Provide a short and direct response. 0.98. What is the ratio of the Value added (current US$) of Manufacturing in 1998 to that in 1999?
Give a very brief answer. 1.01. What is the ratio of the Value added (current US$) of Agriculture in 1998 to that in 1999?
Make the answer very short. 1.07. What is the ratio of the Value added (current US$) in Industry in 1998 to that in 2000?
Provide a succinct answer. 0.77. What is the ratio of the Value added (current US$) of Manufacturing in 1998 to that in 2000?
Offer a terse response. 0.87. What is the ratio of the Value added (current US$) of Services in 1998 to that in 2000?
Offer a terse response. 0.78. What is the ratio of the Value added (current US$) of Agriculture in 1998 to that in 2000?
Your response must be concise. 0.97. What is the ratio of the Value added (current US$) in Industry in 1998 to that in 2001?
Your answer should be compact. 0.87. What is the ratio of the Value added (current US$) of Manufacturing in 1998 to that in 2001?
Keep it short and to the point. 0.8. What is the ratio of the Value added (current US$) of Services in 1998 to that in 2001?
Your response must be concise. 0.88. What is the ratio of the Value added (current US$) in Agriculture in 1998 to that in 2001?
Offer a very short reply. 1.09. What is the ratio of the Value added (current US$) in Industry in 1999 to that in 2000?
Offer a very short reply. 0.79. What is the ratio of the Value added (current US$) of Manufacturing in 1999 to that in 2000?
Provide a short and direct response. 0.86. What is the ratio of the Value added (current US$) of Services in 1999 to that in 2000?
Make the answer very short. 0.78. What is the ratio of the Value added (current US$) in Agriculture in 1999 to that in 2000?
Ensure brevity in your answer.  0.91. What is the ratio of the Value added (current US$) in Industry in 1999 to that in 2001?
Give a very brief answer. 0.89. What is the ratio of the Value added (current US$) in Manufacturing in 1999 to that in 2001?
Make the answer very short. 0.79. What is the ratio of the Value added (current US$) in Services in 1999 to that in 2001?
Provide a short and direct response. 0.88. What is the ratio of the Value added (current US$) in Agriculture in 1999 to that in 2001?
Your answer should be very brief. 1.02. What is the ratio of the Value added (current US$) in Industry in 2000 to that in 2001?
Make the answer very short. 1.13. What is the ratio of the Value added (current US$) in Manufacturing in 2000 to that in 2001?
Make the answer very short. 0.92. What is the ratio of the Value added (current US$) in Services in 2000 to that in 2001?
Provide a succinct answer. 1.13. What is the ratio of the Value added (current US$) of Agriculture in 2000 to that in 2001?
Make the answer very short. 1.12. What is the difference between the highest and the second highest Value added (current US$) of Industry?
Make the answer very short. 2.87e+09. What is the difference between the highest and the second highest Value added (current US$) in Manufacturing?
Keep it short and to the point. 2.77e+09. What is the difference between the highest and the second highest Value added (current US$) in Services?
Provide a succinct answer. 5.14e+09. What is the difference between the highest and the second highest Value added (current US$) of Agriculture?
Your answer should be very brief. 4.10e+08. What is the difference between the highest and the lowest Value added (current US$) in Industry?
Offer a very short reply. 9.43e+09. What is the difference between the highest and the lowest Value added (current US$) in Manufacturing?
Your answer should be compact. 1.49e+1. What is the difference between the highest and the lowest Value added (current US$) of Services?
Provide a succinct answer. 1.45e+1. What is the difference between the highest and the lowest Value added (current US$) in Agriculture?
Ensure brevity in your answer.  4.48e+09. 